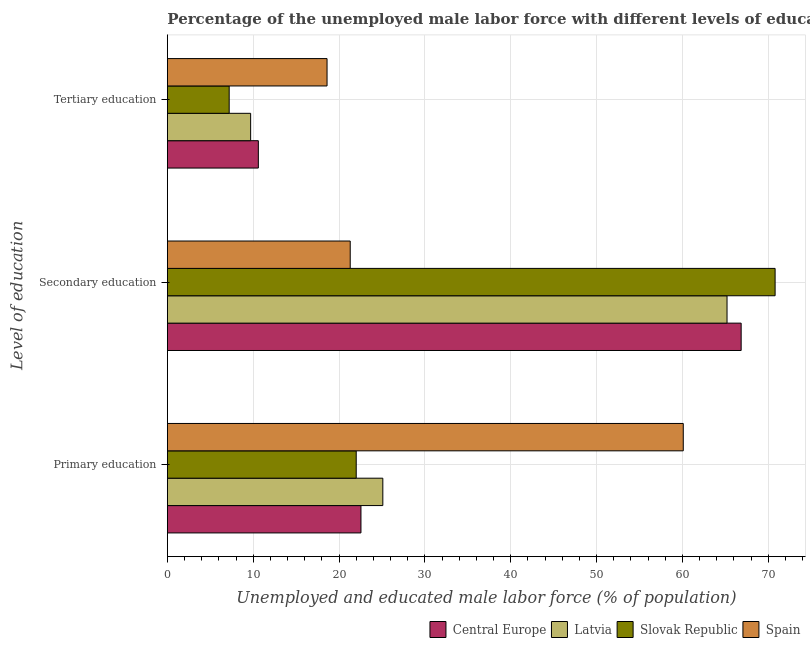How many different coloured bars are there?
Your response must be concise. 4. How many groups of bars are there?
Your answer should be compact. 3. What is the label of the 1st group of bars from the top?
Ensure brevity in your answer.  Tertiary education. Across all countries, what is the maximum percentage of male labor force who received primary education?
Your answer should be very brief. 60.1. Across all countries, what is the minimum percentage of male labor force who received secondary education?
Your answer should be very brief. 21.3. In which country was the percentage of male labor force who received tertiary education minimum?
Offer a very short reply. Slovak Republic. What is the total percentage of male labor force who received primary education in the graph?
Your answer should be very brief. 129.75. What is the difference between the percentage of male labor force who received primary education in Slovak Republic and that in Central Europe?
Ensure brevity in your answer.  -0.55. What is the difference between the percentage of male labor force who received tertiary education in Latvia and the percentage of male labor force who received secondary education in Spain?
Your response must be concise. -11.6. What is the average percentage of male labor force who received tertiary education per country?
Your response must be concise. 11.52. What is the difference between the percentage of male labor force who received primary education and percentage of male labor force who received tertiary education in Spain?
Provide a short and direct response. 41.5. What is the ratio of the percentage of male labor force who received primary education in Latvia to that in Central Europe?
Offer a terse response. 1.11. Is the percentage of male labor force who received tertiary education in Spain less than that in Central Europe?
Provide a short and direct response. No. Is the difference between the percentage of male labor force who received tertiary education in Slovak Republic and Latvia greater than the difference between the percentage of male labor force who received secondary education in Slovak Republic and Latvia?
Give a very brief answer. No. What is the difference between the highest and the second highest percentage of male labor force who received primary education?
Provide a short and direct response. 35. What is the difference between the highest and the lowest percentage of male labor force who received secondary education?
Give a very brief answer. 49.5. In how many countries, is the percentage of male labor force who received primary education greater than the average percentage of male labor force who received primary education taken over all countries?
Make the answer very short. 1. Is the sum of the percentage of male labor force who received primary education in Latvia and Central Europe greater than the maximum percentage of male labor force who received tertiary education across all countries?
Your answer should be very brief. Yes. What does the 4th bar from the top in Tertiary education represents?
Your answer should be compact. Central Europe. What does the 1st bar from the bottom in Primary education represents?
Offer a terse response. Central Europe. Is it the case that in every country, the sum of the percentage of male labor force who received primary education and percentage of male labor force who received secondary education is greater than the percentage of male labor force who received tertiary education?
Offer a terse response. Yes. How many countries are there in the graph?
Your answer should be compact. 4. What is the difference between two consecutive major ticks on the X-axis?
Keep it short and to the point. 10. Are the values on the major ticks of X-axis written in scientific E-notation?
Offer a very short reply. No. Does the graph contain grids?
Your answer should be very brief. Yes. What is the title of the graph?
Provide a short and direct response. Percentage of the unemployed male labor force with different levels of education in countries. Does "Kyrgyz Republic" appear as one of the legend labels in the graph?
Ensure brevity in your answer.  No. What is the label or title of the X-axis?
Give a very brief answer. Unemployed and educated male labor force (% of population). What is the label or title of the Y-axis?
Provide a succinct answer. Level of education. What is the Unemployed and educated male labor force (% of population) of Central Europe in Primary education?
Your answer should be very brief. 22.55. What is the Unemployed and educated male labor force (% of population) in Latvia in Primary education?
Offer a very short reply. 25.1. What is the Unemployed and educated male labor force (% of population) of Slovak Republic in Primary education?
Ensure brevity in your answer.  22. What is the Unemployed and educated male labor force (% of population) in Spain in Primary education?
Give a very brief answer. 60.1. What is the Unemployed and educated male labor force (% of population) of Central Europe in Secondary education?
Your answer should be compact. 66.85. What is the Unemployed and educated male labor force (% of population) in Latvia in Secondary education?
Make the answer very short. 65.2. What is the Unemployed and educated male labor force (% of population) in Slovak Republic in Secondary education?
Offer a terse response. 70.8. What is the Unemployed and educated male labor force (% of population) in Spain in Secondary education?
Your answer should be compact. 21.3. What is the Unemployed and educated male labor force (% of population) of Central Europe in Tertiary education?
Offer a terse response. 10.6. What is the Unemployed and educated male labor force (% of population) in Latvia in Tertiary education?
Your answer should be very brief. 9.7. What is the Unemployed and educated male labor force (% of population) in Slovak Republic in Tertiary education?
Your answer should be compact. 7.2. What is the Unemployed and educated male labor force (% of population) of Spain in Tertiary education?
Give a very brief answer. 18.6. Across all Level of education, what is the maximum Unemployed and educated male labor force (% of population) of Central Europe?
Offer a very short reply. 66.85. Across all Level of education, what is the maximum Unemployed and educated male labor force (% of population) in Latvia?
Offer a very short reply. 65.2. Across all Level of education, what is the maximum Unemployed and educated male labor force (% of population) in Slovak Republic?
Provide a succinct answer. 70.8. Across all Level of education, what is the maximum Unemployed and educated male labor force (% of population) of Spain?
Ensure brevity in your answer.  60.1. Across all Level of education, what is the minimum Unemployed and educated male labor force (% of population) of Central Europe?
Offer a very short reply. 10.6. Across all Level of education, what is the minimum Unemployed and educated male labor force (% of population) in Latvia?
Your answer should be very brief. 9.7. Across all Level of education, what is the minimum Unemployed and educated male labor force (% of population) in Slovak Republic?
Ensure brevity in your answer.  7.2. Across all Level of education, what is the minimum Unemployed and educated male labor force (% of population) in Spain?
Provide a short and direct response. 18.6. What is the total Unemployed and educated male labor force (% of population) of Central Europe in the graph?
Your answer should be compact. 99.99. What is the total Unemployed and educated male labor force (% of population) of Spain in the graph?
Give a very brief answer. 100. What is the difference between the Unemployed and educated male labor force (% of population) in Central Europe in Primary education and that in Secondary education?
Ensure brevity in your answer.  -44.29. What is the difference between the Unemployed and educated male labor force (% of population) of Latvia in Primary education and that in Secondary education?
Ensure brevity in your answer.  -40.1. What is the difference between the Unemployed and educated male labor force (% of population) of Slovak Republic in Primary education and that in Secondary education?
Your answer should be very brief. -48.8. What is the difference between the Unemployed and educated male labor force (% of population) of Spain in Primary education and that in Secondary education?
Offer a terse response. 38.8. What is the difference between the Unemployed and educated male labor force (% of population) of Central Europe in Primary education and that in Tertiary education?
Your answer should be very brief. 11.95. What is the difference between the Unemployed and educated male labor force (% of population) of Latvia in Primary education and that in Tertiary education?
Offer a terse response. 15.4. What is the difference between the Unemployed and educated male labor force (% of population) of Slovak Republic in Primary education and that in Tertiary education?
Offer a terse response. 14.8. What is the difference between the Unemployed and educated male labor force (% of population) in Spain in Primary education and that in Tertiary education?
Offer a very short reply. 41.5. What is the difference between the Unemployed and educated male labor force (% of population) of Central Europe in Secondary education and that in Tertiary education?
Provide a short and direct response. 56.25. What is the difference between the Unemployed and educated male labor force (% of population) in Latvia in Secondary education and that in Tertiary education?
Provide a succinct answer. 55.5. What is the difference between the Unemployed and educated male labor force (% of population) in Slovak Republic in Secondary education and that in Tertiary education?
Ensure brevity in your answer.  63.6. What is the difference between the Unemployed and educated male labor force (% of population) of Spain in Secondary education and that in Tertiary education?
Give a very brief answer. 2.7. What is the difference between the Unemployed and educated male labor force (% of population) in Central Europe in Primary education and the Unemployed and educated male labor force (% of population) in Latvia in Secondary education?
Provide a short and direct response. -42.65. What is the difference between the Unemployed and educated male labor force (% of population) in Central Europe in Primary education and the Unemployed and educated male labor force (% of population) in Slovak Republic in Secondary education?
Your response must be concise. -48.25. What is the difference between the Unemployed and educated male labor force (% of population) in Central Europe in Primary education and the Unemployed and educated male labor force (% of population) in Spain in Secondary education?
Keep it short and to the point. 1.25. What is the difference between the Unemployed and educated male labor force (% of population) in Latvia in Primary education and the Unemployed and educated male labor force (% of population) in Slovak Republic in Secondary education?
Keep it short and to the point. -45.7. What is the difference between the Unemployed and educated male labor force (% of population) of Slovak Republic in Primary education and the Unemployed and educated male labor force (% of population) of Spain in Secondary education?
Your answer should be compact. 0.7. What is the difference between the Unemployed and educated male labor force (% of population) of Central Europe in Primary education and the Unemployed and educated male labor force (% of population) of Latvia in Tertiary education?
Your response must be concise. 12.85. What is the difference between the Unemployed and educated male labor force (% of population) in Central Europe in Primary education and the Unemployed and educated male labor force (% of population) in Slovak Republic in Tertiary education?
Provide a short and direct response. 15.35. What is the difference between the Unemployed and educated male labor force (% of population) in Central Europe in Primary education and the Unemployed and educated male labor force (% of population) in Spain in Tertiary education?
Keep it short and to the point. 3.95. What is the difference between the Unemployed and educated male labor force (% of population) in Slovak Republic in Primary education and the Unemployed and educated male labor force (% of population) in Spain in Tertiary education?
Offer a very short reply. 3.4. What is the difference between the Unemployed and educated male labor force (% of population) in Central Europe in Secondary education and the Unemployed and educated male labor force (% of population) in Latvia in Tertiary education?
Offer a very short reply. 57.15. What is the difference between the Unemployed and educated male labor force (% of population) in Central Europe in Secondary education and the Unemployed and educated male labor force (% of population) in Slovak Republic in Tertiary education?
Your answer should be very brief. 59.65. What is the difference between the Unemployed and educated male labor force (% of population) in Central Europe in Secondary education and the Unemployed and educated male labor force (% of population) in Spain in Tertiary education?
Provide a short and direct response. 48.25. What is the difference between the Unemployed and educated male labor force (% of population) of Latvia in Secondary education and the Unemployed and educated male labor force (% of population) of Slovak Republic in Tertiary education?
Offer a very short reply. 58. What is the difference between the Unemployed and educated male labor force (% of population) of Latvia in Secondary education and the Unemployed and educated male labor force (% of population) of Spain in Tertiary education?
Provide a short and direct response. 46.6. What is the difference between the Unemployed and educated male labor force (% of population) of Slovak Republic in Secondary education and the Unemployed and educated male labor force (% of population) of Spain in Tertiary education?
Make the answer very short. 52.2. What is the average Unemployed and educated male labor force (% of population) of Central Europe per Level of education?
Your response must be concise. 33.33. What is the average Unemployed and educated male labor force (% of population) of Latvia per Level of education?
Ensure brevity in your answer.  33.33. What is the average Unemployed and educated male labor force (% of population) of Slovak Republic per Level of education?
Give a very brief answer. 33.33. What is the average Unemployed and educated male labor force (% of population) of Spain per Level of education?
Provide a succinct answer. 33.33. What is the difference between the Unemployed and educated male labor force (% of population) in Central Europe and Unemployed and educated male labor force (% of population) in Latvia in Primary education?
Offer a terse response. -2.55. What is the difference between the Unemployed and educated male labor force (% of population) of Central Europe and Unemployed and educated male labor force (% of population) of Slovak Republic in Primary education?
Offer a very short reply. 0.55. What is the difference between the Unemployed and educated male labor force (% of population) of Central Europe and Unemployed and educated male labor force (% of population) of Spain in Primary education?
Your answer should be very brief. -37.55. What is the difference between the Unemployed and educated male labor force (% of population) of Latvia and Unemployed and educated male labor force (% of population) of Spain in Primary education?
Provide a short and direct response. -35. What is the difference between the Unemployed and educated male labor force (% of population) of Slovak Republic and Unemployed and educated male labor force (% of population) of Spain in Primary education?
Provide a short and direct response. -38.1. What is the difference between the Unemployed and educated male labor force (% of population) of Central Europe and Unemployed and educated male labor force (% of population) of Latvia in Secondary education?
Your response must be concise. 1.65. What is the difference between the Unemployed and educated male labor force (% of population) of Central Europe and Unemployed and educated male labor force (% of population) of Slovak Republic in Secondary education?
Offer a very short reply. -3.95. What is the difference between the Unemployed and educated male labor force (% of population) in Central Europe and Unemployed and educated male labor force (% of population) in Spain in Secondary education?
Keep it short and to the point. 45.55. What is the difference between the Unemployed and educated male labor force (% of population) in Latvia and Unemployed and educated male labor force (% of population) in Spain in Secondary education?
Offer a terse response. 43.9. What is the difference between the Unemployed and educated male labor force (% of population) in Slovak Republic and Unemployed and educated male labor force (% of population) in Spain in Secondary education?
Make the answer very short. 49.5. What is the difference between the Unemployed and educated male labor force (% of population) of Central Europe and Unemployed and educated male labor force (% of population) of Latvia in Tertiary education?
Your response must be concise. 0.9. What is the difference between the Unemployed and educated male labor force (% of population) in Central Europe and Unemployed and educated male labor force (% of population) in Slovak Republic in Tertiary education?
Offer a terse response. 3.4. What is the difference between the Unemployed and educated male labor force (% of population) in Central Europe and Unemployed and educated male labor force (% of population) in Spain in Tertiary education?
Your answer should be compact. -8. What is the difference between the Unemployed and educated male labor force (% of population) in Latvia and Unemployed and educated male labor force (% of population) in Slovak Republic in Tertiary education?
Ensure brevity in your answer.  2.5. What is the difference between the Unemployed and educated male labor force (% of population) in Slovak Republic and Unemployed and educated male labor force (% of population) in Spain in Tertiary education?
Your answer should be very brief. -11.4. What is the ratio of the Unemployed and educated male labor force (% of population) in Central Europe in Primary education to that in Secondary education?
Your answer should be very brief. 0.34. What is the ratio of the Unemployed and educated male labor force (% of population) of Latvia in Primary education to that in Secondary education?
Give a very brief answer. 0.39. What is the ratio of the Unemployed and educated male labor force (% of population) of Slovak Republic in Primary education to that in Secondary education?
Ensure brevity in your answer.  0.31. What is the ratio of the Unemployed and educated male labor force (% of population) in Spain in Primary education to that in Secondary education?
Provide a succinct answer. 2.82. What is the ratio of the Unemployed and educated male labor force (% of population) in Central Europe in Primary education to that in Tertiary education?
Provide a short and direct response. 2.13. What is the ratio of the Unemployed and educated male labor force (% of population) in Latvia in Primary education to that in Tertiary education?
Make the answer very short. 2.59. What is the ratio of the Unemployed and educated male labor force (% of population) in Slovak Republic in Primary education to that in Tertiary education?
Your answer should be compact. 3.06. What is the ratio of the Unemployed and educated male labor force (% of population) of Spain in Primary education to that in Tertiary education?
Provide a short and direct response. 3.23. What is the ratio of the Unemployed and educated male labor force (% of population) of Central Europe in Secondary education to that in Tertiary education?
Keep it short and to the point. 6.31. What is the ratio of the Unemployed and educated male labor force (% of population) in Latvia in Secondary education to that in Tertiary education?
Your answer should be compact. 6.72. What is the ratio of the Unemployed and educated male labor force (% of population) of Slovak Republic in Secondary education to that in Tertiary education?
Provide a short and direct response. 9.83. What is the ratio of the Unemployed and educated male labor force (% of population) of Spain in Secondary education to that in Tertiary education?
Ensure brevity in your answer.  1.15. What is the difference between the highest and the second highest Unemployed and educated male labor force (% of population) of Central Europe?
Offer a very short reply. 44.29. What is the difference between the highest and the second highest Unemployed and educated male labor force (% of population) in Latvia?
Offer a terse response. 40.1. What is the difference between the highest and the second highest Unemployed and educated male labor force (% of population) in Slovak Republic?
Make the answer very short. 48.8. What is the difference between the highest and the second highest Unemployed and educated male labor force (% of population) in Spain?
Offer a very short reply. 38.8. What is the difference between the highest and the lowest Unemployed and educated male labor force (% of population) of Central Europe?
Provide a short and direct response. 56.25. What is the difference between the highest and the lowest Unemployed and educated male labor force (% of population) of Latvia?
Offer a terse response. 55.5. What is the difference between the highest and the lowest Unemployed and educated male labor force (% of population) in Slovak Republic?
Your answer should be compact. 63.6. What is the difference between the highest and the lowest Unemployed and educated male labor force (% of population) of Spain?
Your response must be concise. 41.5. 